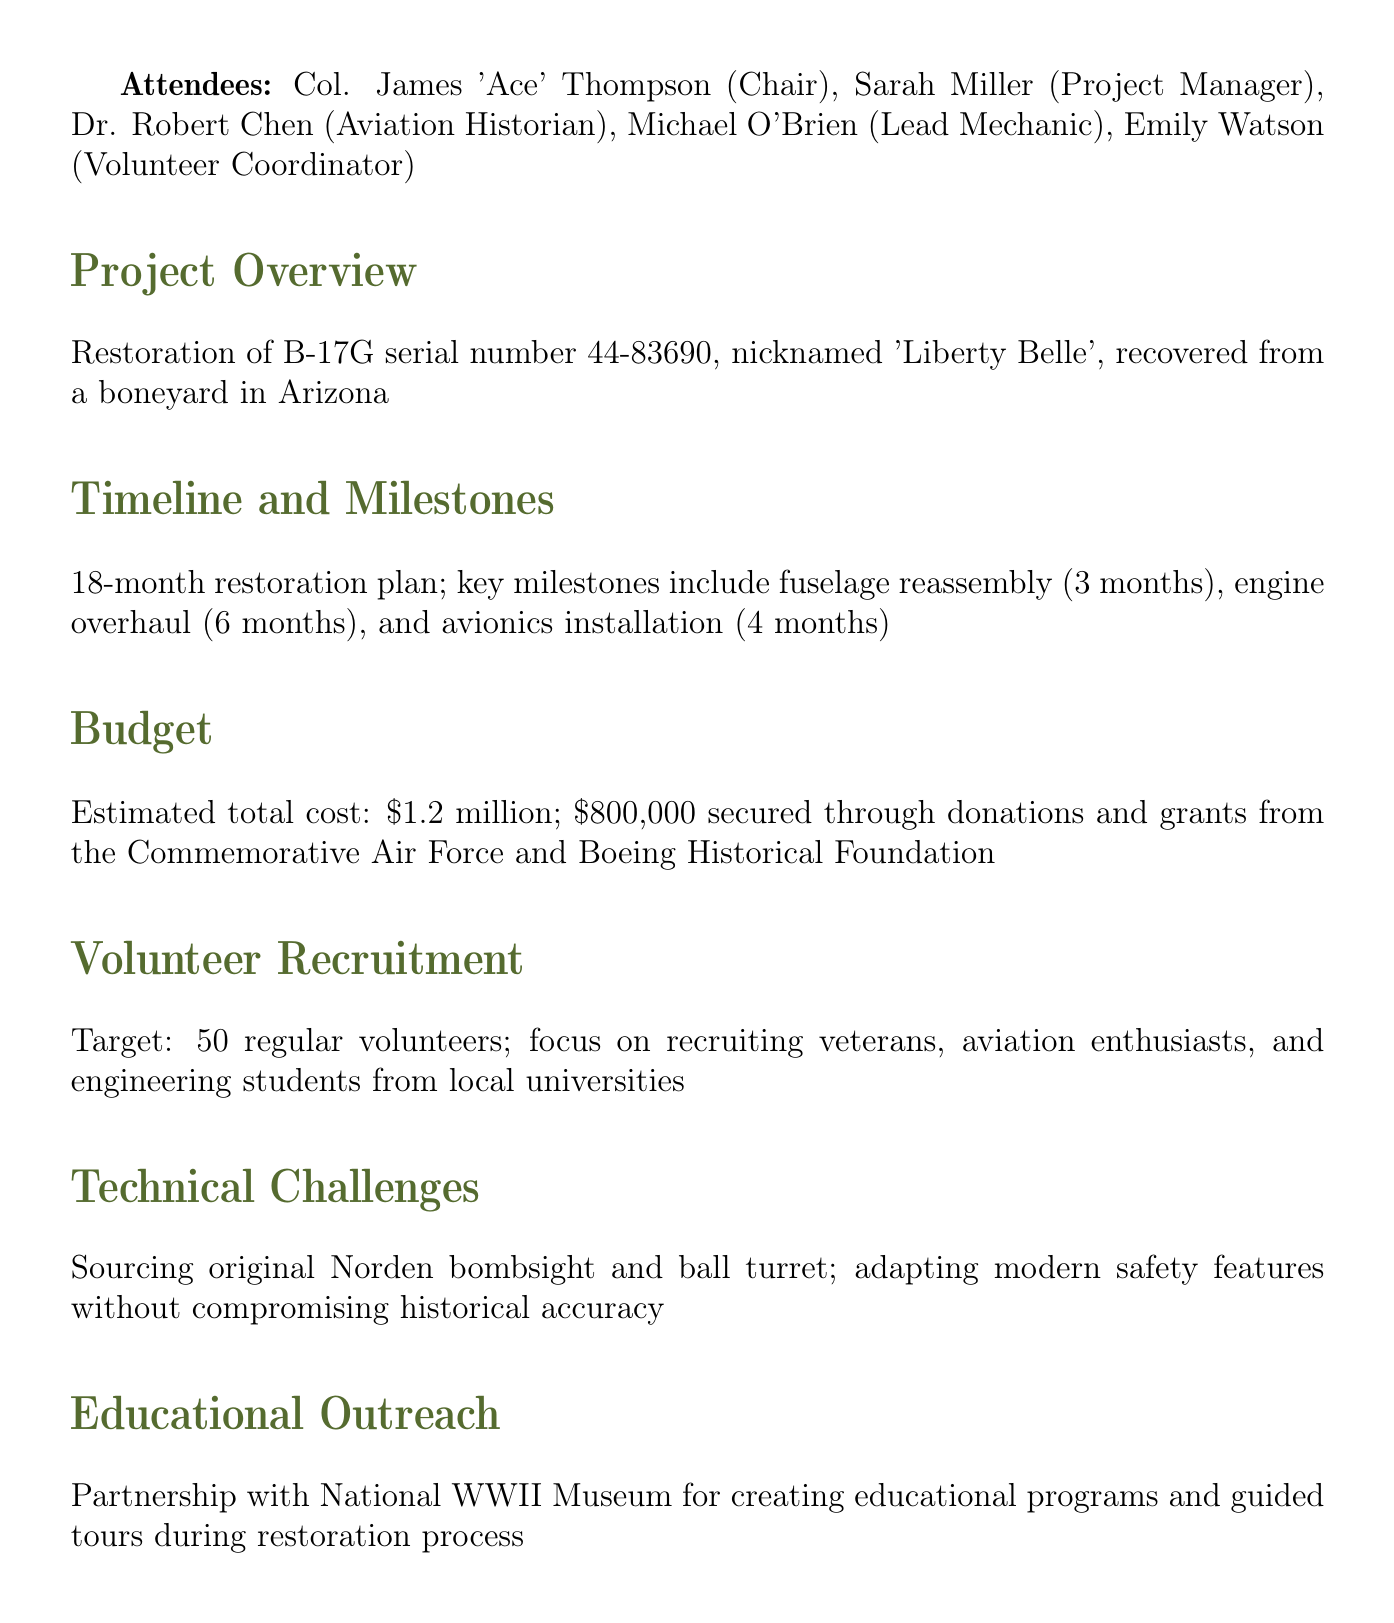What is the aircraft restoration project discussed? The restoration project focuses on the B-17G serial number 44-83690, nicknamed 'Liberty Belle'.
Answer: B-17G serial number 44-83690, nicknamed 'Liberty Belle' Who is the chair of the meeting? The chair of the meeting is Colonel James 'Ace' Thompson.
Answer: Col. James 'Ace' Thompson What is the estimated total cost of the project? The estimated total cost of the restoration project is detailed in the document, amounting to $1.2 million.
Answer: $1.2 million What is the target number of regular volunteers? The project aims to recruit 50 regular volunteers as stated in the document.
Answer: 50 What is the milestone for the engine overhaul? The timeline for the engine overhaul of the restoration is set to take 6 months.
Answer: 6 months What is one of the technical challenges mentioned? One of the technical challenges involves sourcing the original Norden bombsight.
Answer: Sourcing original Norden bombsight When is the volunteer orientation session scheduled? The document specifies that the volunteer orientation session is planned for July 1st.
Answer: July 1st Who will finalize the hangar lease? The responsibility for finalizing the hangar lease at Willow Run Airport lies with Sarah Miller.
Answer: Sarah What partnership is mentioned for educational outreach? The project is partnering with the National WWII Museum for educational programs.
Answer: National WWII Museum 